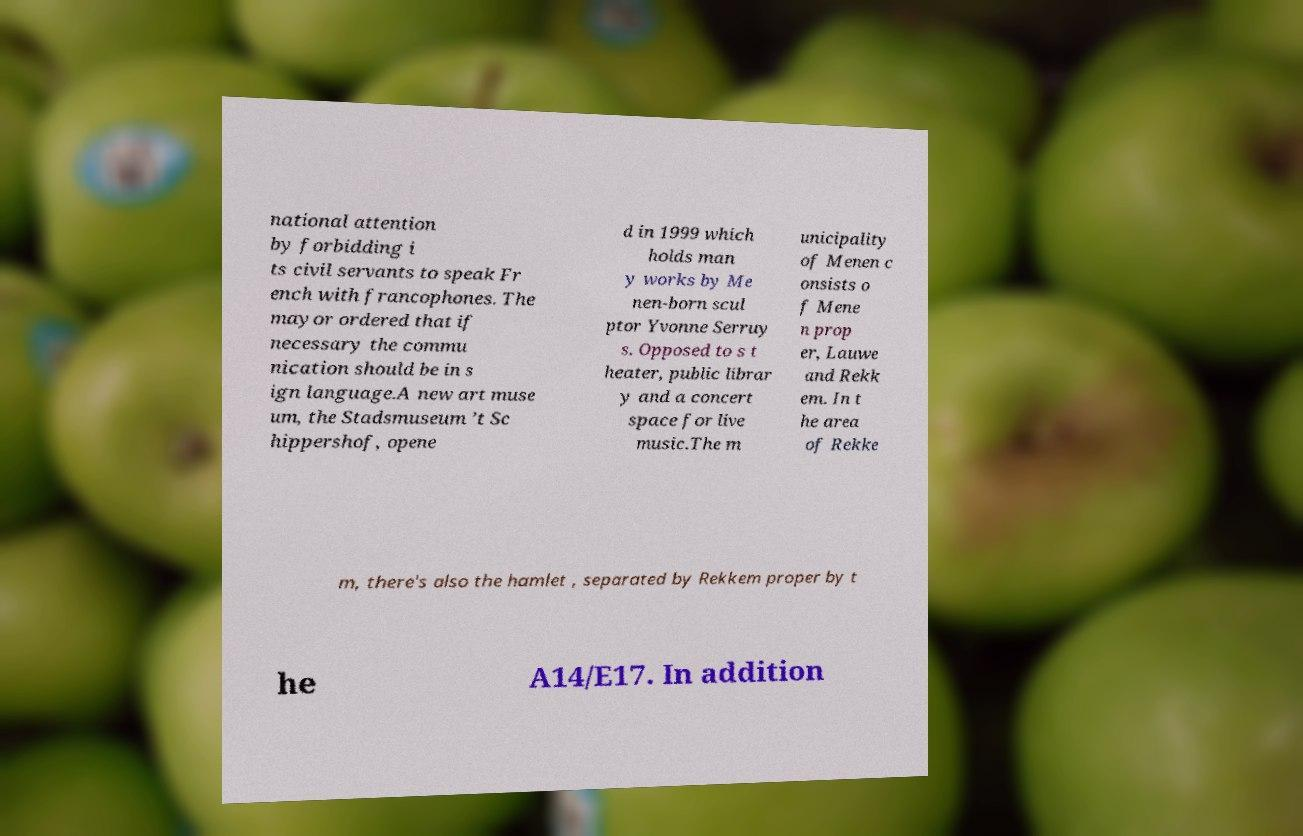Can you accurately transcribe the text from the provided image for me? national attention by forbidding i ts civil servants to speak Fr ench with francophones. The mayor ordered that if necessary the commu nication should be in s ign language.A new art muse um, the Stadsmuseum ’t Sc hippershof, opene d in 1999 which holds man y works by Me nen-born scul ptor Yvonne Serruy s. Opposed to s t heater, public librar y and a concert space for live music.The m unicipality of Menen c onsists o f Mene n prop er, Lauwe and Rekk em. In t he area of Rekke m, there's also the hamlet , separated by Rekkem proper by t he A14/E17. In addition 